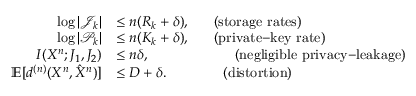<formula> <loc_0><loc_0><loc_500><loc_500>\begin{array} { r l } { \log | \mathcal { J } _ { k } | } & { \leq n ( R _ { k } + \delta ) , ( s t o r a g e r a t e s ) } \\ { \log | \mathcal { P } _ { k } | } & { \leq n ( K _ { k } + \delta ) , ( p r i v a t e \mathrm { - } k e y r a t e ) } \\ { I ( X ^ { n } ; J _ { 1 } , J _ { 2 } ) } & { \leq n \delta , ( n e g l i g i b l e p r i v a c y \mathrm { - } l e a k a g e ) } \\ { \mathbb { E } [ { d ^ { ( n ) } } ( X ^ { n } , \hat { X } ^ { n } ) ] } & { \leq { D + \delta } . ( d i s t o r t i o n ) } \end{array}</formula> 